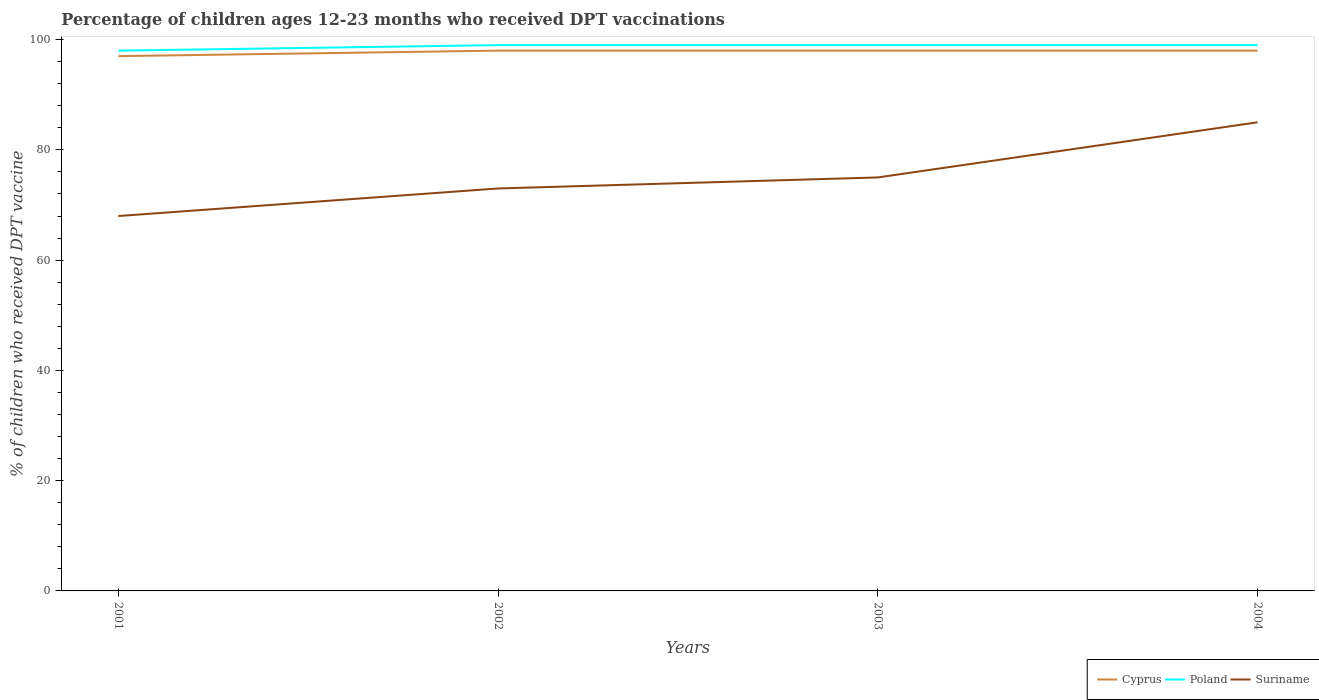How many different coloured lines are there?
Offer a very short reply. 3. Across all years, what is the maximum percentage of children who received DPT vaccination in Suriname?
Offer a terse response. 68. What is the difference between the highest and the second highest percentage of children who received DPT vaccination in Suriname?
Provide a succinct answer. 17. How many lines are there?
Offer a terse response. 3. Does the graph contain any zero values?
Provide a succinct answer. No. Where does the legend appear in the graph?
Keep it short and to the point. Bottom right. How many legend labels are there?
Make the answer very short. 3. How are the legend labels stacked?
Your response must be concise. Horizontal. What is the title of the graph?
Offer a terse response. Percentage of children ages 12-23 months who received DPT vaccinations. What is the label or title of the Y-axis?
Ensure brevity in your answer.  % of children who received DPT vaccine. What is the % of children who received DPT vaccine of Cyprus in 2001?
Your response must be concise. 97. What is the % of children who received DPT vaccine of Suriname in 2001?
Offer a very short reply. 68. What is the % of children who received DPT vaccine of Cyprus in 2002?
Keep it short and to the point. 98. What is the % of children who received DPT vaccine in Suriname in 2002?
Ensure brevity in your answer.  73. What is the % of children who received DPT vaccine of Cyprus in 2003?
Ensure brevity in your answer.  98. What is the % of children who received DPT vaccine of Suriname in 2003?
Your response must be concise. 75. What is the % of children who received DPT vaccine of Suriname in 2004?
Keep it short and to the point. 85. Across all years, what is the minimum % of children who received DPT vaccine in Cyprus?
Offer a very short reply. 97. What is the total % of children who received DPT vaccine in Cyprus in the graph?
Ensure brevity in your answer.  391. What is the total % of children who received DPT vaccine in Poland in the graph?
Ensure brevity in your answer.  395. What is the total % of children who received DPT vaccine of Suriname in the graph?
Offer a very short reply. 301. What is the difference between the % of children who received DPT vaccine of Cyprus in 2001 and that in 2002?
Your response must be concise. -1. What is the difference between the % of children who received DPT vaccine of Suriname in 2001 and that in 2002?
Provide a short and direct response. -5. What is the difference between the % of children who received DPT vaccine of Cyprus in 2001 and that in 2004?
Ensure brevity in your answer.  -1. What is the difference between the % of children who received DPT vaccine of Suriname in 2002 and that in 2003?
Offer a very short reply. -2. What is the difference between the % of children who received DPT vaccine in Poland in 2002 and that in 2004?
Keep it short and to the point. 0. What is the difference between the % of children who received DPT vaccine in Suriname in 2002 and that in 2004?
Provide a succinct answer. -12. What is the difference between the % of children who received DPT vaccine of Cyprus in 2001 and the % of children who received DPT vaccine of Poland in 2002?
Offer a terse response. -2. What is the difference between the % of children who received DPT vaccine in Cyprus in 2001 and the % of children who received DPT vaccine in Suriname in 2002?
Your response must be concise. 24. What is the difference between the % of children who received DPT vaccine in Poland in 2001 and the % of children who received DPT vaccine in Suriname in 2002?
Make the answer very short. 25. What is the difference between the % of children who received DPT vaccine in Cyprus in 2001 and the % of children who received DPT vaccine in Poland in 2003?
Provide a short and direct response. -2. What is the difference between the % of children who received DPT vaccine of Cyprus in 2001 and the % of children who received DPT vaccine of Suriname in 2003?
Your answer should be compact. 22. What is the difference between the % of children who received DPT vaccine in Cyprus in 2001 and the % of children who received DPT vaccine in Suriname in 2004?
Your answer should be compact. 12. What is the difference between the % of children who received DPT vaccine of Poland in 2001 and the % of children who received DPT vaccine of Suriname in 2004?
Keep it short and to the point. 13. What is the difference between the % of children who received DPT vaccine in Cyprus in 2002 and the % of children who received DPT vaccine in Poland in 2003?
Your answer should be compact. -1. What is the difference between the % of children who received DPT vaccine of Poland in 2002 and the % of children who received DPT vaccine of Suriname in 2003?
Provide a short and direct response. 24. What is the difference between the % of children who received DPT vaccine of Cyprus in 2002 and the % of children who received DPT vaccine of Poland in 2004?
Ensure brevity in your answer.  -1. What is the difference between the % of children who received DPT vaccine of Poland in 2002 and the % of children who received DPT vaccine of Suriname in 2004?
Ensure brevity in your answer.  14. What is the difference between the % of children who received DPT vaccine of Cyprus in 2003 and the % of children who received DPT vaccine of Suriname in 2004?
Provide a short and direct response. 13. What is the difference between the % of children who received DPT vaccine of Poland in 2003 and the % of children who received DPT vaccine of Suriname in 2004?
Offer a very short reply. 14. What is the average % of children who received DPT vaccine in Cyprus per year?
Ensure brevity in your answer.  97.75. What is the average % of children who received DPT vaccine of Poland per year?
Your answer should be very brief. 98.75. What is the average % of children who received DPT vaccine in Suriname per year?
Keep it short and to the point. 75.25. In the year 2002, what is the difference between the % of children who received DPT vaccine in Cyprus and % of children who received DPT vaccine in Suriname?
Offer a terse response. 25. In the year 2002, what is the difference between the % of children who received DPT vaccine in Poland and % of children who received DPT vaccine in Suriname?
Offer a terse response. 26. In the year 2003, what is the difference between the % of children who received DPT vaccine in Cyprus and % of children who received DPT vaccine in Poland?
Offer a very short reply. -1. In the year 2003, what is the difference between the % of children who received DPT vaccine of Cyprus and % of children who received DPT vaccine of Suriname?
Your response must be concise. 23. In the year 2003, what is the difference between the % of children who received DPT vaccine of Poland and % of children who received DPT vaccine of Suriname?
Provide a short and direct response. 24. In the year 2004, what is the difference between the % of children who received DPT vaccine of Cyprus and % of children who received DPT vaccine of Poland?
Your answer should be very brief. -1. In the year 2004, what is the difference between the % of children who received DPT vaccine of Cyprus and % of children who received DPT vaccine of Suriname?
Ensure brevity in your answer.  13. What is the ratio of the % of children who received DPT vaccine in Suriname in 2001 to that in 2002?
Provide a short and direct response. 0.93. What is the ratio of the % of children who received DPT vaccine in Cyprus in 2001 to that in 2003?
Your response must be concise. 0.99. What is the ratio of the % of children who received DPT vaccine in Suriname in 2001 to that in 2003?
Make the answer very short. 0.91. What is the ratio of the % of children who received DPT vaccine in Cyprus in 2001 to that in 2004?
Your answer should be very brief. 0.99. What is the ratio of the % of children who received DPT vaccine in Poland in 2001 to that in 2004?
Offer a terse response. 0.99. What is the ratio of the % of children who received DPT vaccine of Suriname in 2001 to that in 2004?
Make the answer very short. 0.8. What is the ratio of the % of children who received DPT vaccine of Cyprus in 2002 to that in 2003?
Your answer should be compact. 1. What is the ratio of the % of children who received DPT vaccine of Poland in 2002 to that in 2003?
Your answer should be very brief. 1. What is the ratio of the % of children who received DPT vaccine in Suriname in 2002 to that in 2003?
Your answer should be compact. 0.97. What is the ratio of the % of children who received DPT vaccine in Suriname in 2002 to that in 2004?
Give a very brief answer. 0.86. What is the ratio of the % of children who received DPT vaccine of Cyprus in 2003 to that in 2004?
Your answer should be compact. 1. What is the ratio of the % of children who received DPT vaccine in Suriname in 2003 to that in 2004?
Provide a succinct answer. 0.88. What is the difference between the highest and the second highest % of children who received DPT vaccine in Poland?
Your response must be concise. 0. What is the difference between the highest and the lowest % of children who received DPT vaccine of Cyprus?
Keep it short and to the point. 1. What is the difference between the highest and the lowest % of children who received DPT vaccine of Suriname?
Your response must be concise. 17. 